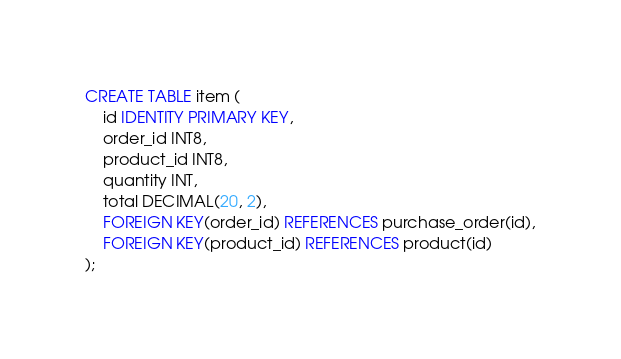<code> <loc_0><loc_0><loc_500><loc_500><_SQL_>CREATE TABLE item (
    id IDENTITY PRIMARY KEY,
    order_id INT8,
    product_id INT8,
    quantity INT,
    total DECIMAL(20, 2),
    FOREIGN KEY(order_id) REFERENCES purchase_order(id),
    FOREIGN KEY(product_id) REFERENCES product(id)
);</code> 